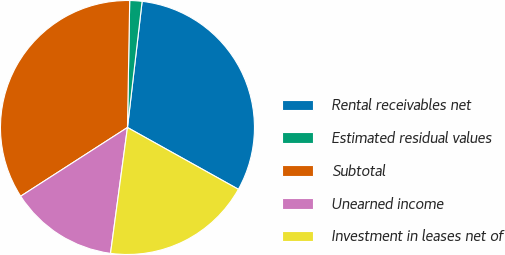Convert chart. <chart><loc_0><loc_0><loc_500><loc_500><pie_chart><fcel>Rental receivables net<fcel>Estimated residual values<fcel>Subtotal<fcel>Unearned income<fcel>Investment in leases net of<nl><fcel>31.25%<fcel>1.56%<fcel>34.38%<fcel>13.77%<fcel>19.04%<nl></chart> 